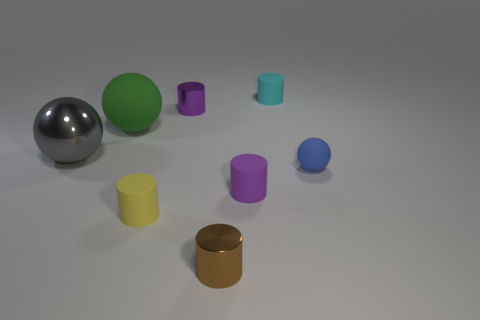Is the size of the cyan cylinder the same as the green ball that is in front of the small cyan thing?
Give a very brief answer. No. What size is the yellow rubber object that is the same shape as the tiny brown metallic object?
Offer a terse response. Small. There is a rubber sphere that is on the left side of the small yellow matte cylinder; does it have the same size as the shiny cylinder that is to the left of the brown cylinder?
Your response must be concise. No. How many tiny objects are purple things or purple shiny objects?
Your response must be concise. 2. What number of shiny objects are to the right of the big shiny ball and behind the tiny blue thing?
Your answer should be very brief. 1. Does the yellow cylinder have the same material as the purple object behind the big rubber thing?
Provide a succinct answer. No. What number of green objects are matte cylinders or metallic objects?
Offer a terse response. 0. Are there any gray things of the same size as the green ball?
Offer a terse response. Yes. There is a tiny purple cylinder behind the big sphere that is in front of the rubber sphere that is behind the blue matte ball; what is its material?
Your response must be concise. Metal. Is the number of tiny cyan matte cylinders that are in front of the small brown cylinder the same as the number of tiny red metallic blocks?
Make the answer very short. Yes. 